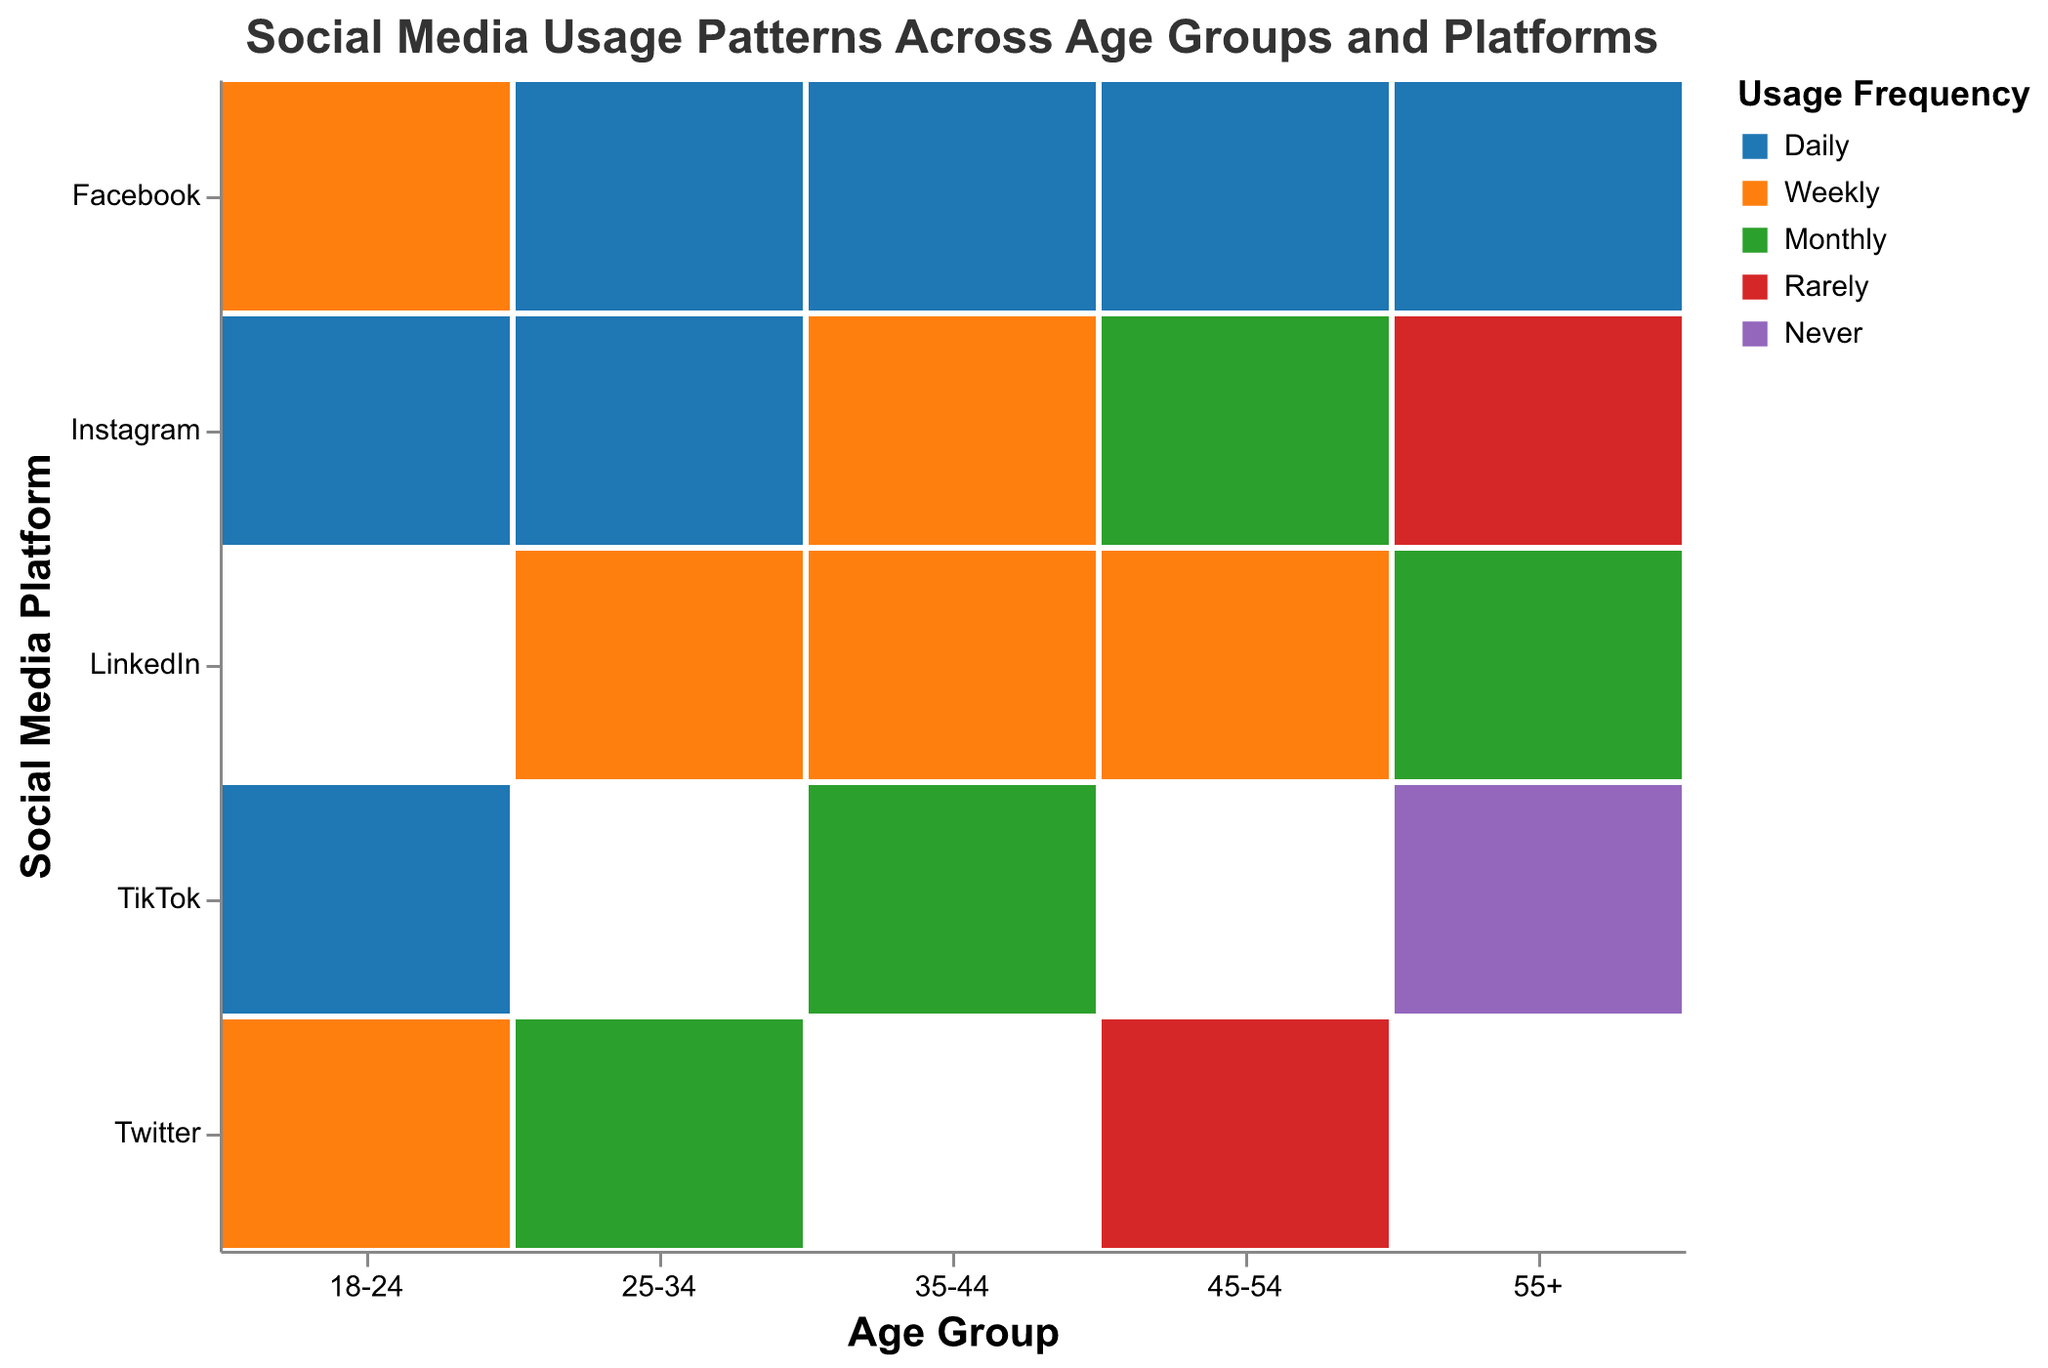What is the title of the figure? The title of the figure is typically located at the top and summarizes the content or purpose of the figure. In this case, it mentions the "Social Media Usage Patterns Across Age Groups and Platforms."
Answer: Social Media Usage Patterns Across Age Groups and Platforms Which age group uses Facebook daily? To identify which age groups use Facebook daily, we look for bars in the row corresponding to 'Facebook' and check the colors representing 'Daily.'
Answer: 25-34, 35-44, 45-54, 55+ How frequently does the age group 55+ use TikTok? We find the column corresponding to age group '55+' and locate the row for 'TikTok.' The color will indicate the usage frequency.
Answer: Never What is the most common usage frequency for Instagram in the age group of 18-24? Within the 18-24 column, look at the Instagram row and identify the most predominant color, which represents the frequency.
Answer: Daily Which platform is used weekly by both 25-34 and 35-44 age groups? Find common usage frequencies in the 'Weekly' color for both age groups within their respective columns. Scan each platform row to find overlaps.
Answer: LinkedIn Between the age groups 18-24 and 45-54, which group uses Instagram more frequently? Look at the Instagram row for both age groups and compare the usage colors to see which indicates more frequent usage.
Answer: 18-24 How does the Twitter usage of the 25-34 age group compare to that of the 45-54 age group? Compare the color bars in the Twitter row for both age groups to assess their usages.
Answer: 25-34: Monthly, 45-54: Rarely What is the median frequency of LinkedIn usage across all age groups? List LinkedIn usage frequencies for each age group, sort these frequencies, and find the middle value. Sequence: Weekly, Weekly, Weekly, Weekly, Monthly
Answer: Weekly How many platforms does the 35-44 age group use on a daily basis? Count the 'Daily' colors in the 35-44 age group's column across all platform rows.
Answer: One (Facebook) Is there any age group that uses Instagram rarely? Search through the Instagram row and check if any columns are marked with the color for 'Rarely.'
Answer: Yes, 55+ 